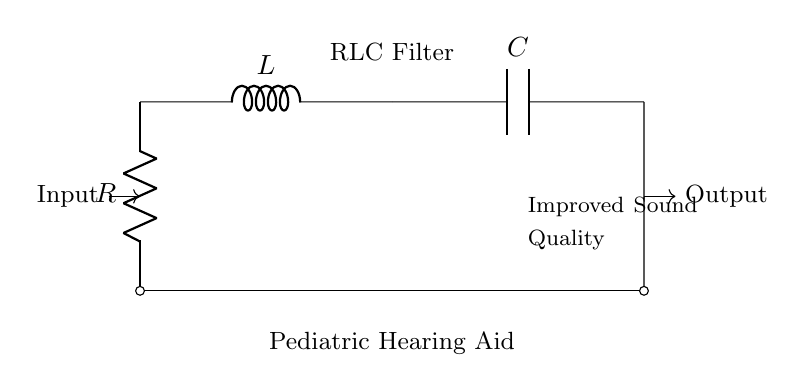what does R represent in the circuit? R represents the resistor in the circuit, which is used to limit the current flow.
Answer: Resistor what is the purpose of the inductor L in this circuit? The inductor L in the circuit is used to store energy in a magnetic field and can help in controlling the frequency response of the filter.
Answer: Energy storage what is C in the circuit? C is the capacitor, which stores electrical energy and helps smooth out voltage fluctuations.
Answer: Capacitor how many components are there in total in this circuit diagram? There are three main components in this RLC filter circuit: one resistor, one inductor, and one capacitor.
Answer: Three what type of filter does this circuit represent? This circuit represents an RLC filter, which can be used to filter signals based on their frequencies.
Answer: RLC filter if the input is an audio signal, what is the overall benefit of this circuit? The overall benefit of this circuit is to improve sound quality by filtering out unwanted frequencies and allowing desired frequencies to pass through.
Answer: Improved sound quality how does the presence of both R and L affect the circuit's response to high frequencies? The presence of both R and L creates a damping effect, which reduces the amplitude of high-frequency signals, thereby helping to enhance sound quality for desired frequency ranges.
Answer: Damping effect 